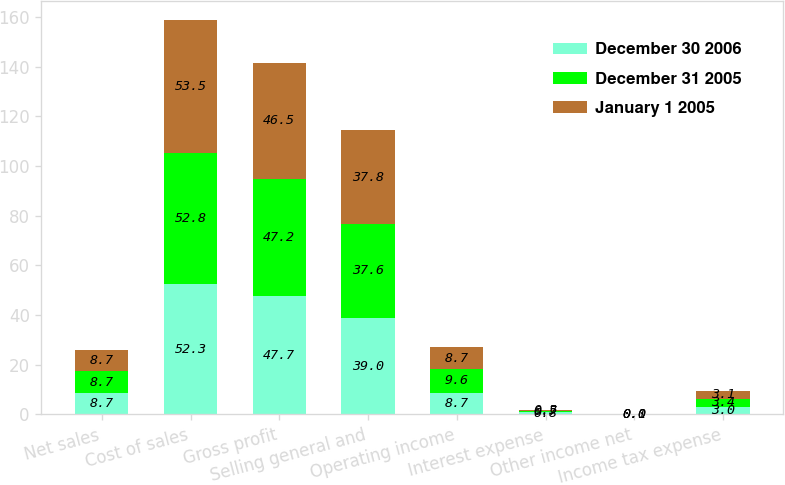Convert chart to OTSL. <chart><loc_0><loc_0><loc_500><loc_500><stacked_bar_chart><ecel><fcel>Net sales<fcel>Cost of sales<fcel>Gross profit<fcel>Selling general and<fcel>Operating income<fcel>Interest expense<fcel>Other income net<fcel>Income tax expense<nl><fcel>December 30 2006<fcel>8.7<fcel>52.3<fcel>47.7<fcel>39<fcel>8.7<fcel>0.8<fcel>0.1<fcel>3<nl><fcel>December 31 2005<fcel>8.7<fcel>52.8<fcel>47.2<fcel>37.6<fcel>9.6<fcel>0.7<fcel>0<fcel>3.4<nl><fcel>January 1 2005<fcel>8.7<fcel>53.5<fcel>46.5<fcel>37.8<fcel>8.7<fcel>0.5<fcel>0<fcel>3.1<nl></chart> 